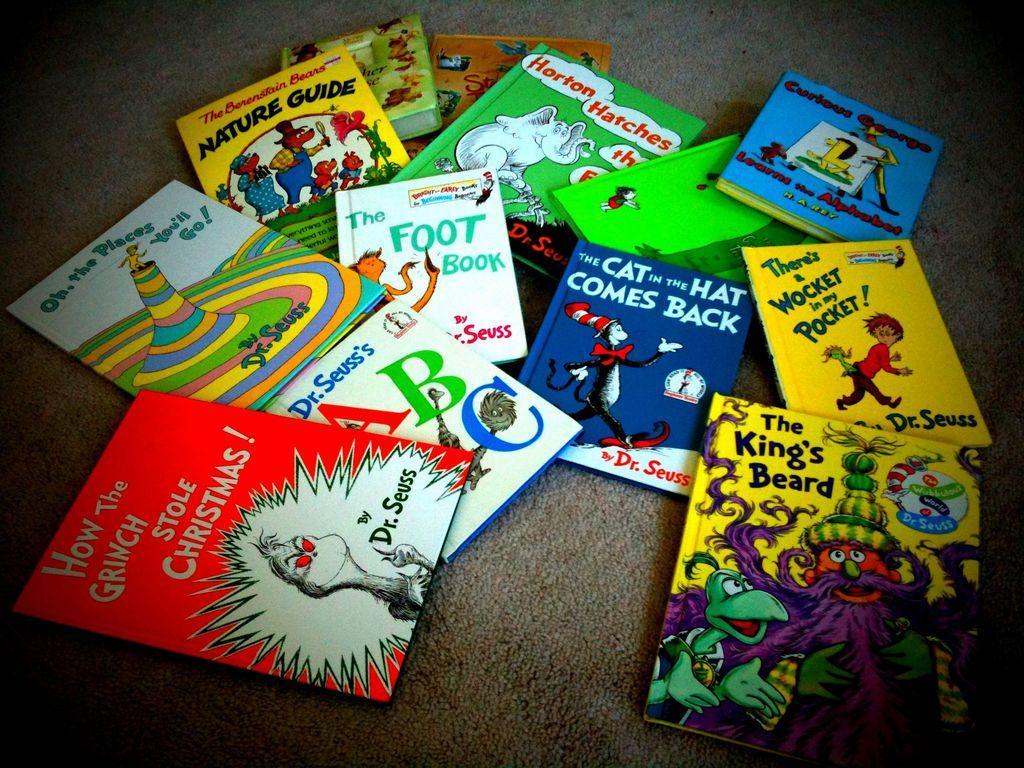Can you describe this image briefly? In this image we can see books on a surface. On the books we can see text and cartoon images. 